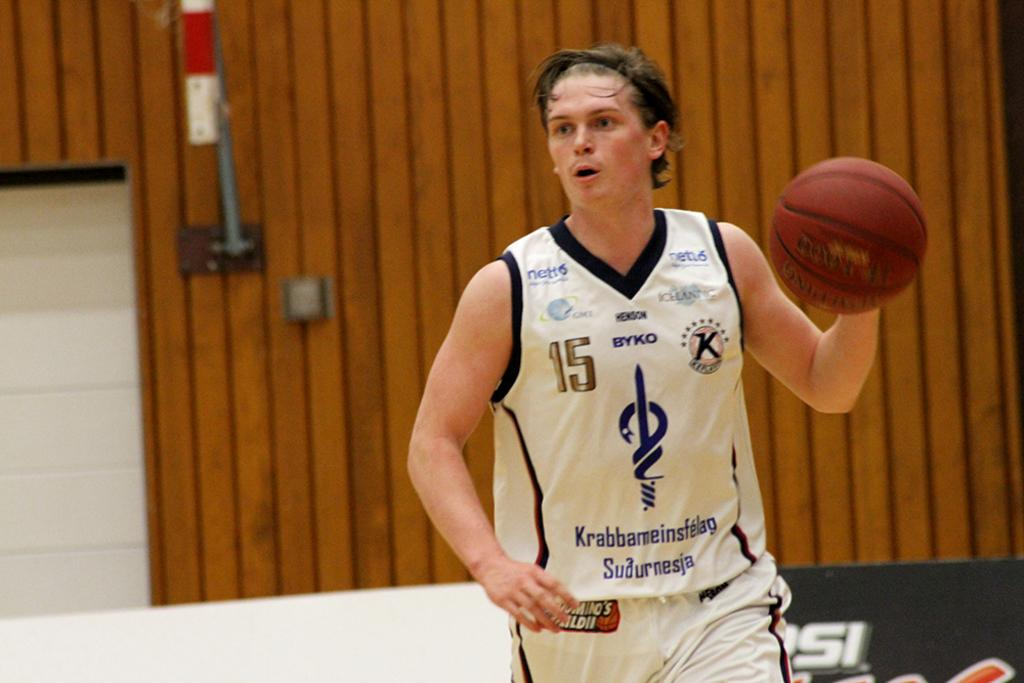<image>
Share a concise interpretation of the image provided. Number 15 has the basketball and is looking ahead. 